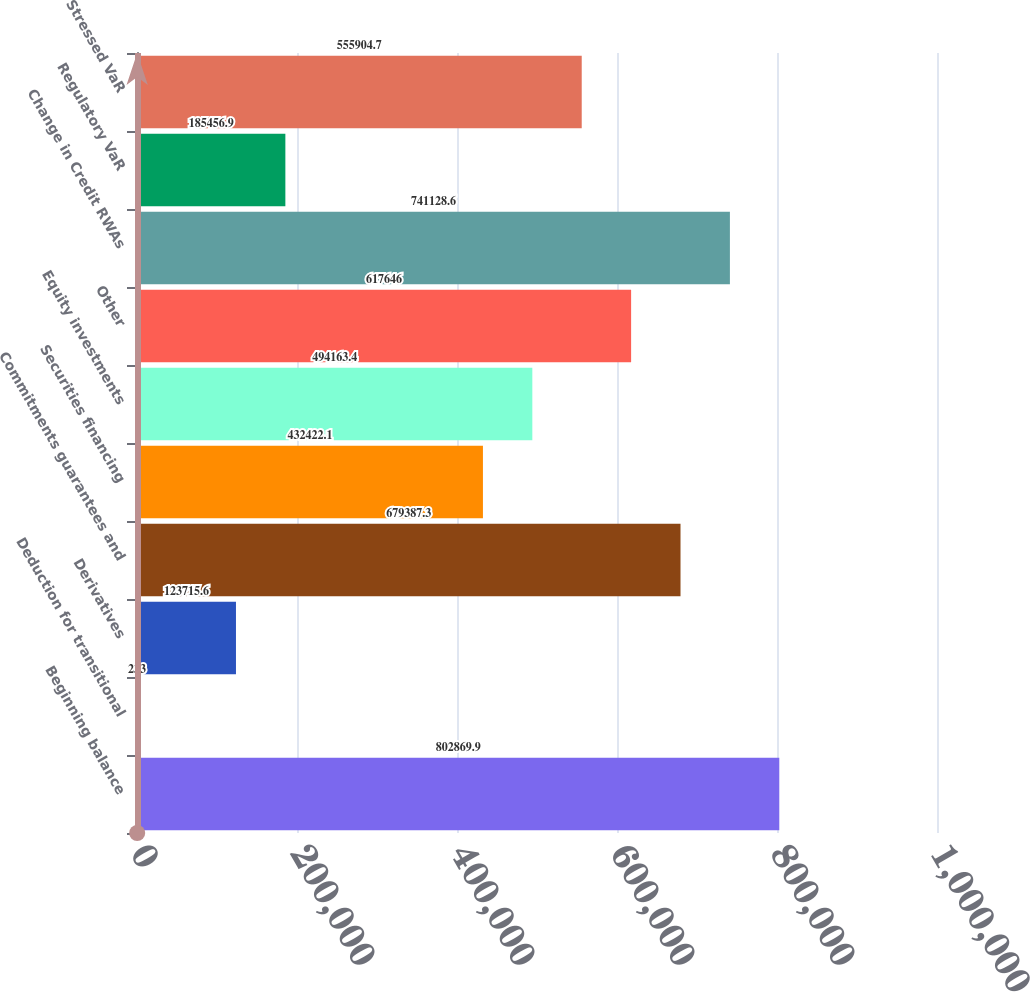Convert chart. <chart><loc_0><loc_0><loc_500><loc_500><bar_chart><fcel>Beginning balance<fcel>Deduction for transitional<fcel>Derivatives<fcel>Commitments guarantees and<fcel>Securities financing<fcel>Equity investments<fcel>Other<fcel>Change in Credit RWAs<fcel>Regulatory VaR<fcel>Stressed VaR<nl><fcel>802870<fcel>233<fcel>123716<fcel>679387<fcel>432422<fcel>494163<fcel>617646<fcel>741129<fcel>185457<fcel>555905<nl></chart> 